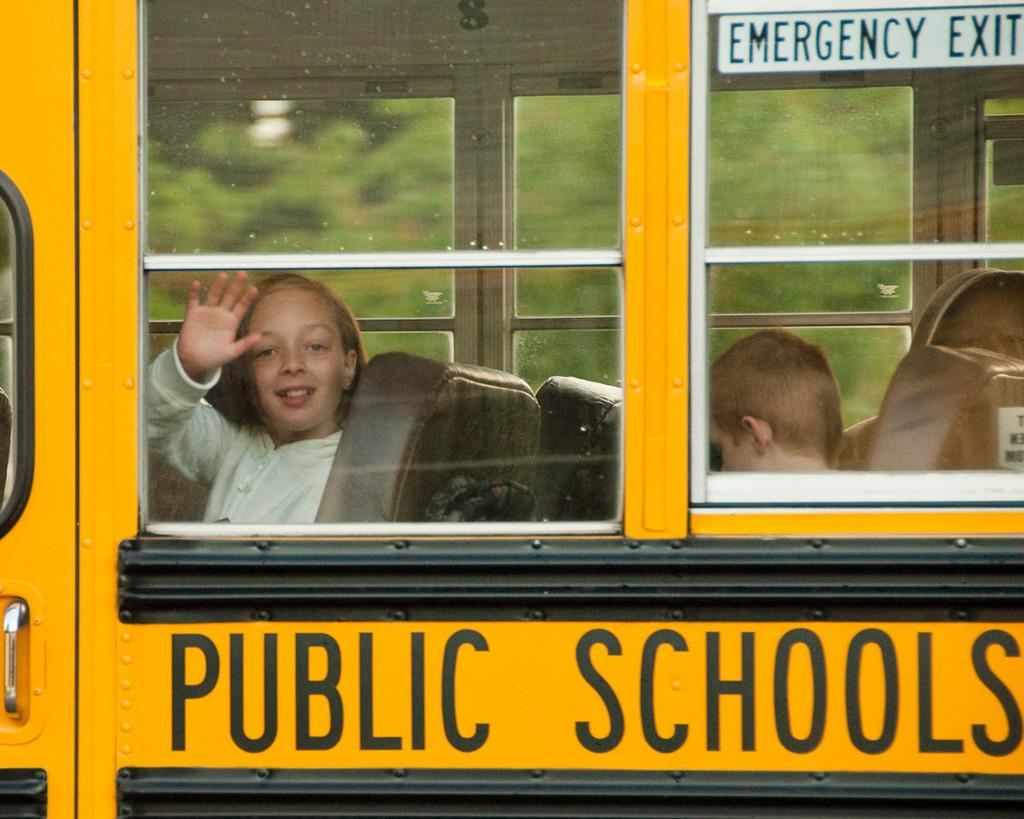What is the main subject of the picture? The main subject of the picture is a school bus. What can be seen inside the school bus? There is a girl sitting in the chairs and a boy sitting in the chairs inside the school bus. What is written on the school bus? There is text on the bus. Is there any text visible on the glass of the school bus? Yes, there is text on the glass. What can be seen through the glass of the school bus? Trees are visible through the glass. What type of silk is draped over the fifth chair in the image? There is no silk or fifth chair present in the image. Is there a gun visible in the image? There is no gun present in the image. 